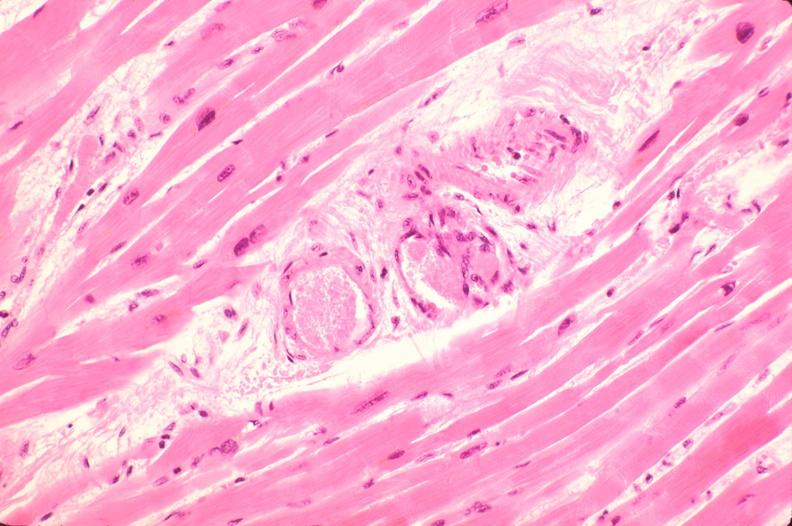s cardiovascular present?
Answer the question using a single word or phrase. Yes 